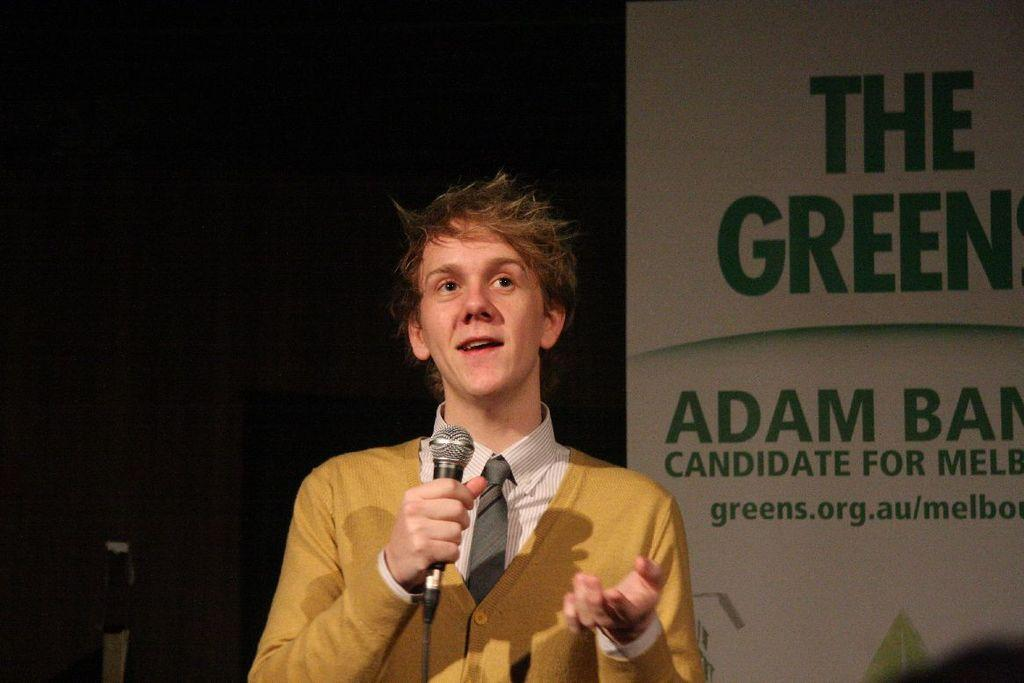Who or what is present in the image? There is a person in the image. What is the person holding in the image? The person is holding a microphone. What else can be seen in the image besides the person and the microphone? There is a board with text in the image. How many seeds can be seen on the board in the image? There are no seeds present on the board in the image. What type of store is visible in the image? There is no store visible in the image. 